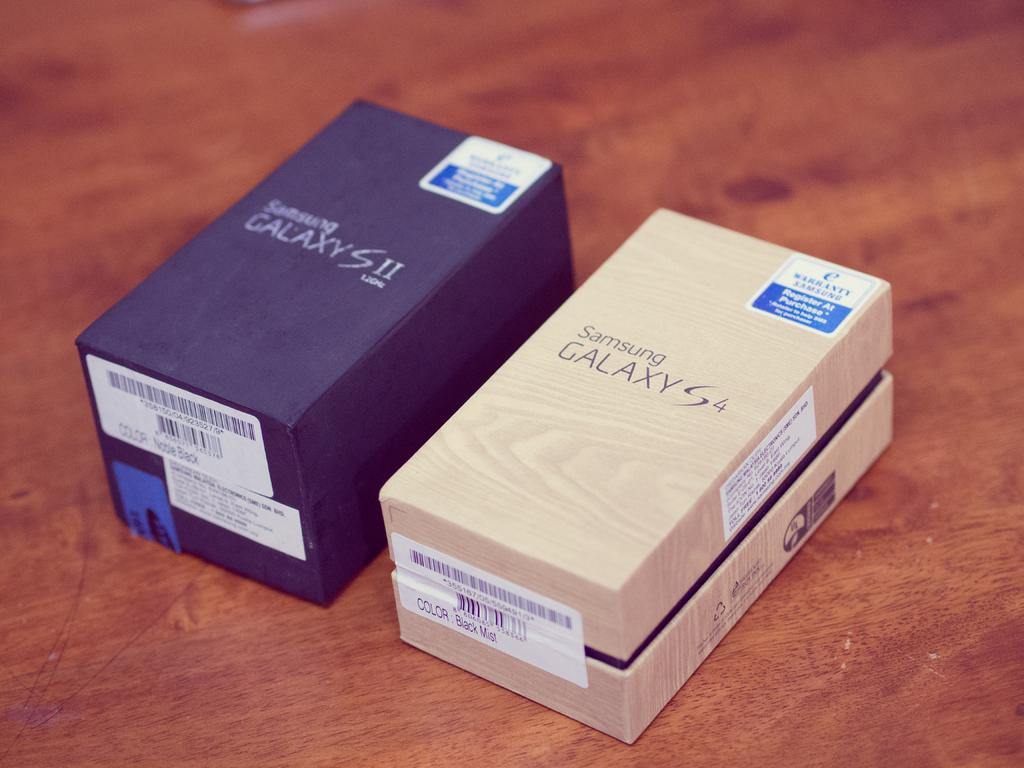<image>
Create a compact narrative representing the image presented. Two galaxy phones in a box one is a two and other one is four 